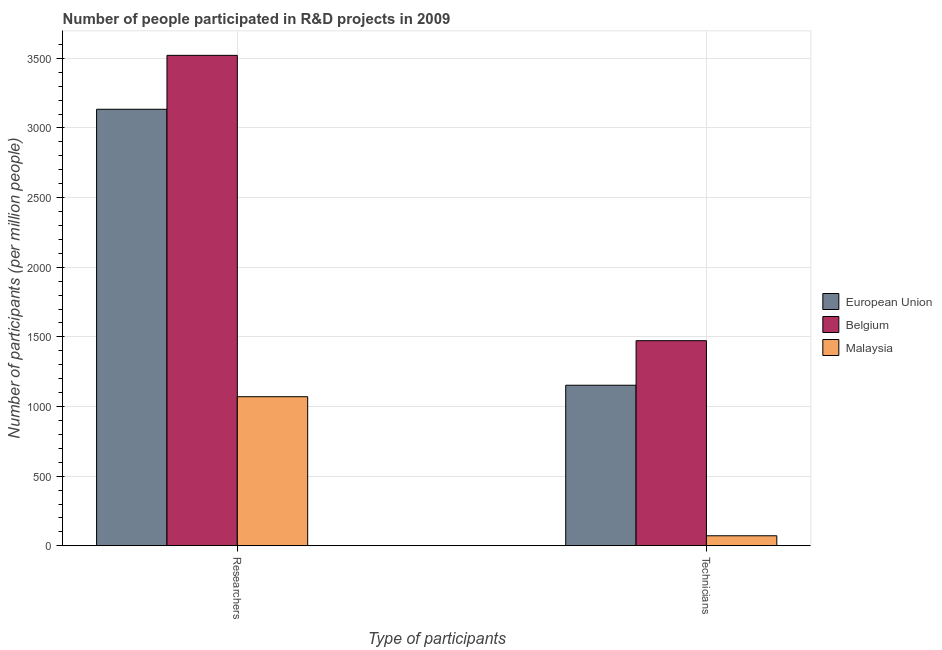How many groups of bars are there?
Provide a short and direct response. 2. How many bars are there on the 1st tick from the left?
Give a very brief answer. 3. How many bars are there on the 2nd tick from the right?
Ensure brevity in your answer.  3. What is the label of the 1st group of bars from the left?
Your response must be concise. Researchers. What is the number of technicians in Malaysia?
Offer a very short reply. 71.82. Across all countries, what is the maximum number of technicians?
Your response must be concise. 1472.61. Across all countries, what is the minimum number of researchers?
Your answer should be compact. 1070.39. In which country was the number of technicians maximum?
Make the answer very short. Belgium. In which country was the number of technicians minimum?
Provide a succinct answer. Malaysia. What is the total number of researchers in the graph?
Provide a short and direct response. 7726.45. What is the difference between the number of researchers in Belgium and that in European Union?
Offer a very short reply. 387.25. What is the difference between the number of researchers in European Union and the number of technicians in Malaysia?
Your response must be concise. 3062.59. What is the average number of researchers per country?
Your answer should be very brief. 2575.48. What is the difference between the number of researchers and number of technicians in Belgium?
Give a very brief answer. 2049.04. In how many countries, is the number of researchers greater than 2100 ?
Keep it short and to the point. 2. What is the ratio of the number of technicians in European Union to that in Malaysia?
Offer a terse response. 16.05. Is the number of technicians in Malaysia less than that in European Union?
Ensure brevity in your answer.  Yes. What does the 3rd bar from the left in Researchers represents?
Offer a very short reply. Malaysia. What does the 2nd bar from the right in Technicians represents?
Ensure brevity in your answer.  Belgium. Are all the bars in the graph horizontal?
Provide a succinct answer. No. How many countries are there in the graph?
Your answer should be compact. 3. What is the difference between two consecutive major ticks on the Y-axis?
Ensure brevity in your answer.  500. Are the values on the major ticks of Y-axis written in scientific E-notation?
Offer a terse response. No. Does the graph contain grids?
Your answer should be very brief. Yes. How many legend labels are there?
Provide a succinct answer. 3. What is the title of the graph?
Make the answer very short. Number of people participated in R&D projects in 2009. Does "Cameroon" appear as one of the legend labels in the graph?
Provide a succinct answer. No. What is the label or title of the X-axis?
Provide a succinct answer. Type of participants. What is the label or title of the Y-axis?
Provide a short and direct response. Number of participants (per million people). What is the Number of participants (per million people) in European Union in Researchers?
Offer a very short reply. 3134.4. What is the Number of participants (per million people) in Belgium in Researchers?
Ensure brevity in your answer.  3521.66. What is the Number of participants (per million people) in Malaysia in Researchers?
Make the answer very short. 1070.39. What is the Number of participants (per million people) of European Union in Technicians?
Your answer should be compact. 1152.73. What is the Number of participants (per million people) in Belgium in Technicians?
Your response must be concise. 1472.61. What is the Number of participants (per million people) in Malaysia in Technicians?
Offer a terse response. 71.82. Across all Type of participants, what is the maximum Number of participants (per million people) in European Union?
Provide a succinct answer. 3134.4. Across all Type of participants, what is the maximum Number of participants (per million people) of Belgium?
Provide a succinct answer. 3521.66. Across all Type of participants, what is the maximum Number of participants (per million people) of Malaysia?
Keep it short and to the point. 1070.39. Across all Type of participants, what is the minimum Number of participants (per million people) of European Union?
Give a very brief answer. 1152.73. Across all Type of participants, what is the minimum Number of participants (per million people) in Belgium?
Your answer should be very brief. 1472.61. Across all Type of participants, what is the minimum Number of participants (per million people) in Malaysia?
Provide a short and direct response. 71.82. What is the total Number of participants (per million people) of European Union in the graph?
Your answer should be compact. 4287.13. What is the total Number of participants (per million people) in Belgium in the graph?
Offer a very short reply. 4994.27. What is the total Number of participants (per million people) in Malaysia in the graph?
Offer a very short reply. 1142.21. What is the difference between the Number of participants (per million people) of European Union in Researchers and that in Technicians?
Your answer should be very brief. 1981.67. What is the difference between the Number of participants (per million people) in Belgium in Researchers and that in Technicians?
Your answer should be very brief. 2049.04. What is the difference between the Number of participants (per million people) of Malaysia in Researchers and that in Technicians?
Ensure brevity in your answer.  998.58. What is the difference between the Number of participants (per million people) in European Union in Researchers and the Number of participants (per million people) in Belgium in Technicians?
Make the answer very short. 1661.79. What is the difference between the Number of participants (per million people) in European Union in Researchers and the Number of participants (per million people) in Malaysia in Technicians?
Offer a very short reply. 3062.59. What is the difference between the Number of participants (per million people) in Belgium in Researchers and the Number of participants (per million people) in Malaysia in Technicians?
Your answer should be compact. 3449.84. What is the average Number of participants (per million people) of European Union per Type of participants?
Offer a terse response. 2143.57. What is the average Number of participants (per million people) of Belgium per Type of participants?
Provide a succinct answer. 2497.13. What is the average Number of participants (per million people) in Malaysia per Type of participants?
Ensure brevity in your answer.  571.1. What is the difference between the Number of participants (per million people) of European Union and Number of participants (per million people) of Belgium in Researchers?
Provide a short and direct response. -387.25. What is the difference between the Number of participants (per million people) of European Union and Number of participants (per million people) of Malaysia in Researchers?
Make the answer very short. 2064.01. What is the difference between the Number of participants (per million people) in Belgium and Number of participants (per million people) in Malaysia in Researchers?
Your answer should be compact. 2451.26. What is the difference between the Number of participants (per million people) of European Union and Number of participants (per million people) of Belgium in Technicians?
Your response must be concise. -319.88. What is the difference between the Number of participants (per million people) of European Union and Number of participants (per million people) of Malaysia in Technicians?
Offer a very short reply. 1080.92. What is the difference between the Number of participants (per million people) in Belgium and Number of participants (per million people) in Malaysia in Technicians?
Your answer should be very brief. 1400.8. What is the ratio of the Number of participants (per million people) in European Union in Researchers to that in Technicians?
Your answer should be compact. 2.72. What is the ratio of the Number of participants (per million people) in Belgium in Researchers to that in Technicians?
Your response must be concise. 2.39. What is the ratio of the Number of participants (per million people) of Malaysia in Researchers to that in Technicians?
Offer a very short reply. 14.9. What is the difference between the highest and the second highest Number of participants (per million people) of European Union?
Provide a succinct answer. 1981.67. What is the difference between the highest and the second highest Number of participants (per million people) of Belgium?
Offer a terse response. 2049.04. What is the difference between the highest and the second highest Number of participants (per million people) of Malaysia?
Your answer should be very brief. 998.58. What is the difference between the highest and the lowest Number of participants (per million people) in European Union?
Your answer should be very brief. 1981.67. What is the difference between the highest and the lowest Number of participants (per million people) in Belgium?
Provide a short and direct response. 2049.04. What is the difference between the highest and the lowest Number of participants (per million people) in Malaysia?
Provide a short and direct response. 998.58. 